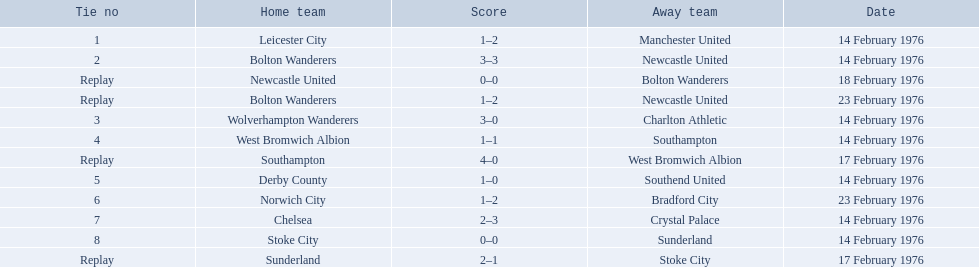Which game holds the highest position on the table? 1. For this game, which team is playing at home? Leicester City. 